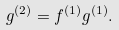<formula> <loc_0><loc_0><loc_500><loc_500>g ^ { ( 2 ) } = f ^ { ( 1 ) } g ^ { ( 1 ) } .</formula> 